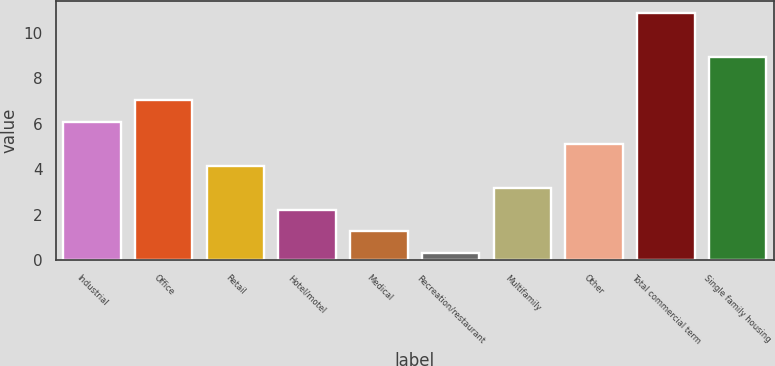<chart> <loc_0><loc_0><loc_500><loc_500><bar_chart><fcel>Industrial<fcel>Office<fcel>Retail<fcel>Hotel/motel<fcel>Medical<fcel>Recreation/restaurant<fcel>Multifamily<fcel>Other<fcel>Total commercial term<fcel>Single family housing<nl><fcel>6.07<fcel>7.03<fcel>4.15<fcel>2.23<fcel>1.27<fcel>0.31<fcel>3.19<fcel>5.11<fcel>10.87<fcel>8.95<nl></chart> 